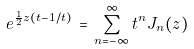Convert formula to latex. <formula><loc_0><loc_0><loc_500><loc_500>e ^ { \frac { 1 } { 2 } z ( t - 1 / t ) } \, = \, \sum _ { n = - \infty } ^ { \infty } t ^ { n } J _ { n } ( z )</formula> 